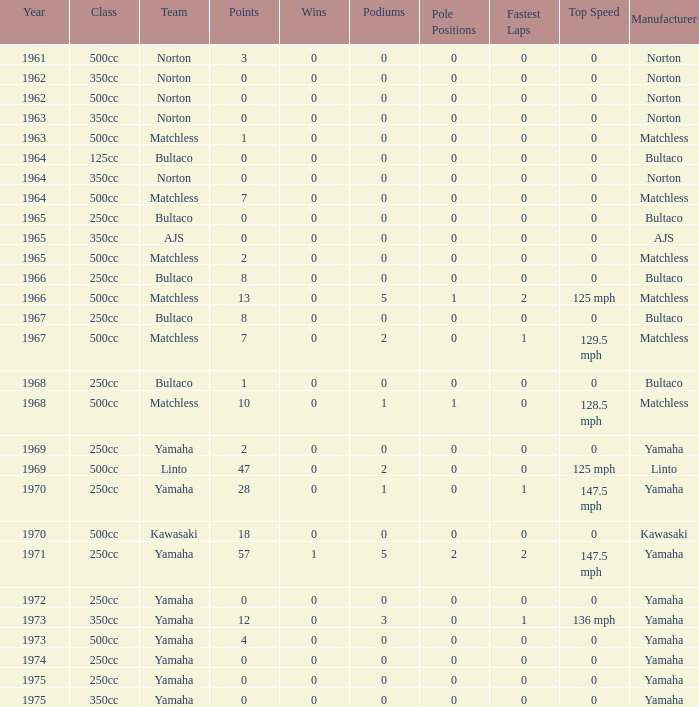What is the sum of all points in 1975 with 0 wins? None. 